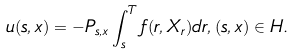Convert formula to latex. <formula><loc_0><loc_0><loc_500><loc_500>u ( s , x ) = - P _ { s , x } \int _ { s } ^ { T } f ( r , X _ { r } ) d r , ( s , x ) \in H .</formula> 